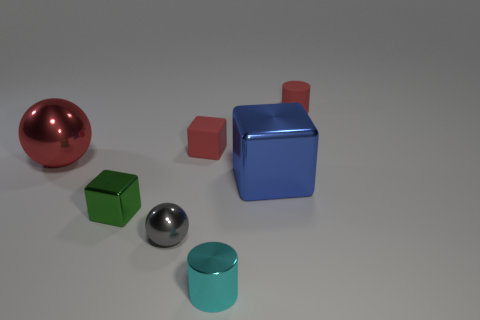Are there an equal number of tiny cyan cylinders left of the large metal sphere and small cyan shiny things?
Give a very brief answer. No. What is the shape of the tiny matte thing that is the same color as the small rubber block?
Your answer should be compact. Cylinder. How many cyan shiny cylinders have the same size as the green metal cube?
Keep it short and to the point. 1. There is a tiny metallic cube; how many tiny cyan cylinders are left of it?
Provide a succinct answer. 0. There is a cylinder that is on the left side of the object that is right of the big blue object; what is its material?
Provide a succinct answer. Metal. Is there a small thing that has the same color as the small rubber cylinder?
Provide a short and direct response. Yes. There is a blue thing that is the same material as the tiny ball; what size is it?
Offer a very short reply. Large. Is there any other thing of the same color as the tiny rubber cylinder?
Provide a succinct answer. Yes. What is the color of the small cylinder that is in front of the blue thing?
Your answer should be compact. Cyan. There is a large metal object that is to the left of the small metal thing to the right of the small gray metal sphere; are there any large objects that are on the right side of it?
Provide a short and direct response. Yes. 